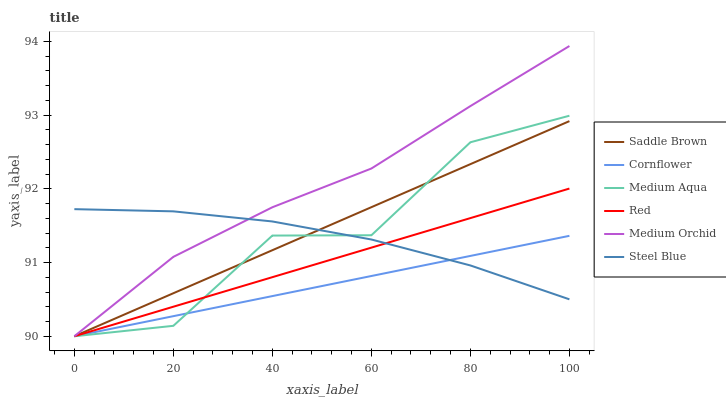Does Cornflower have the minimum area under the curve?
Answer yes or no. Yes. Does Medium Orchid have the maximum area under the curve?
Answer yes or no. Yes. Does Steel Blue have the minimum area under the curve?
Answer yes or no. No. Does Steel Blue have the maximum area under the curve?
Answer yes or no. No. Is Cornflower the smoothest?
Answer yes or no. Yes. Is Medium Aqua the roughest?
Answer yes or no. Yes. Is Medium Orchid the smoothest?
Answer yes or no. No. Is Medium Orchid the roughest?
Answer yes or no. No. Does Cornflower have the lowest value?
Answer yes or no. Yes. Does Steel Blue have the lowest value?
Answer yes or no. No. Does Medium Orchid have the highest value?
Answer yes or no. Yes. Does Steel Blue have the highest value?
Answer yes or no. No. Does Cornflower intersect Steel Blue?
Answer yes or no. Yes. Is Cornflower less than Steel Blue?
Answer yes or no. No. Is Cornflower greater than Steel Blue?
Answer yes or no. No. 